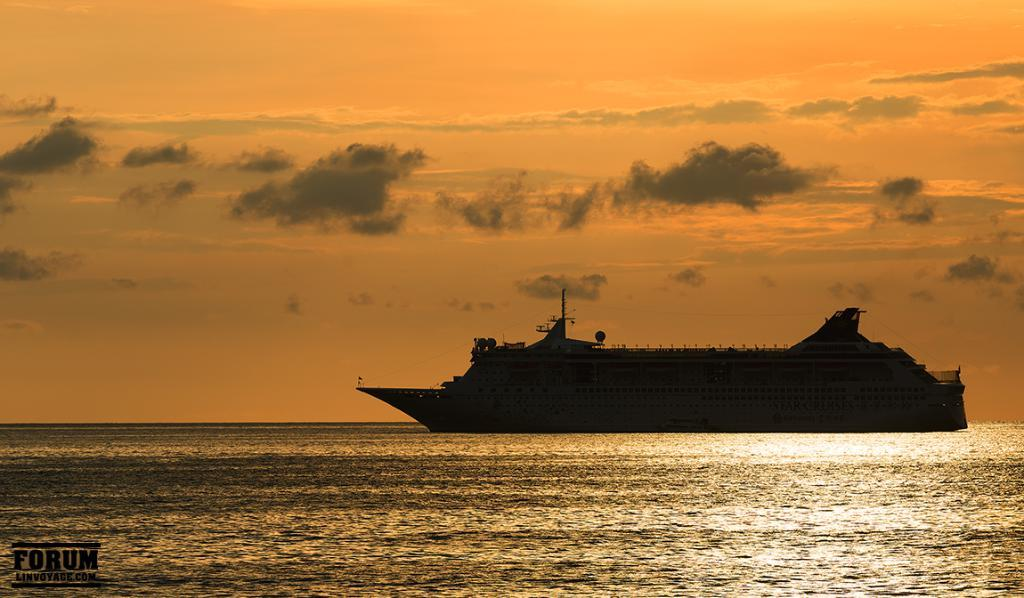What is the main subject of the image? The main subject of the image is a ship. What is the ship doing in the image? The ship is moving on the water in the image. What can be seen at the bottom of the image? There is water visible at the bottom of the image. What is visible in the sky at the top of the image? There are clouds in the sky at the top of the image. What type of teeth can be seen on the ship in the image? There are no teeth visible on the ship in the image. 